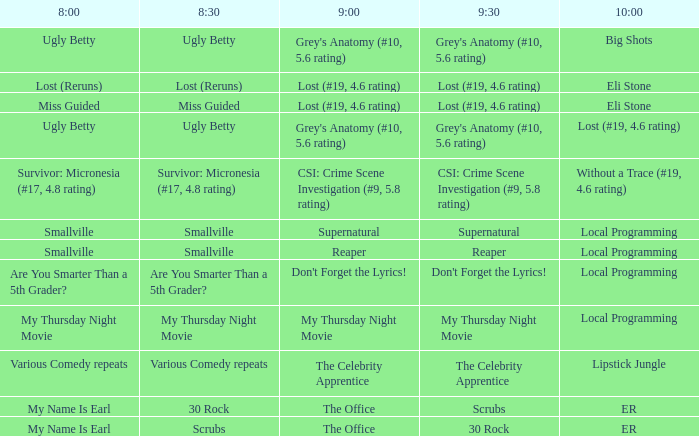What takes place at 10:00 when at 9:00 it is gone (#19, Eli Stone. 